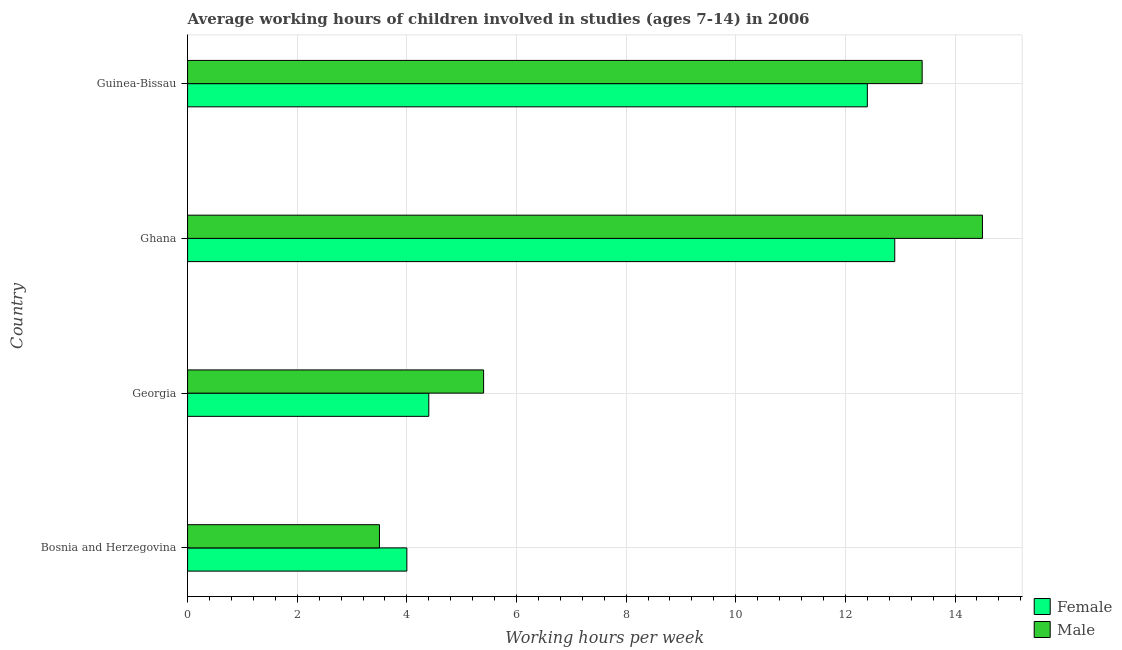How many different coloured bars are there?
Provide a succinct answer. 2. How many groups of bars are there?
Your answer should be compact. 4. Are the number of bars on each tick of the Y-axis equal?
Provide a short and direct response. Yes. How many bars are there on the 1st tick from the top?
Offer a terse response. 2. What is the label of the 3rd group of bars from the top?
Your answer should be very brief. Georgia. Across all countries, what is the minimum average working hour of male children?
Offer a terse response. 3.5. In which country was the average working hour of female children minimum?
Your answer should be very brief. Bosnia and Herzegovina. What is the total average working hour of male children in the graph?
Make the answer very short. 36.8. What is the difference between the average working hour of male children in Georgia and that in Ghana?
Your answer should be very brief. -9.1. What is the difference between the average working hour of male children in Ghana and the average working hour of female children in Bosnia and Herzegovina?
Offer a terse response. 10.5. What is the average average working hour of female children per country?
Make the answer very short. 8.43. In how many countries, is the average working hour of male children greater than 8 hours?
Make the answer very short. 2. What is the ratio of the average working hour of female children in Bosnia and Herzegovina to that in Georgia?
Your answer should be compact. 0.91. In how many countries, is the average working hour of male children greater than the average average working hour of male children taken over all countries?
Keep it short and to the point. 2. What does the 1st bar from the top in Georgia represents?
Give a very brief answer. Male. What does the 2nd bar from the bottom in Guinea-Bissau represents?
Your response must be concise. Male. What is the difference between two consecutive major ticks on the X-axis?
Provide a short and direct response. 2. Does the graph contain grids?
Ensure brevity in your answer.  Yes. Where does the legend appear in the graph?
Ensure brevity in your answer.  Bottom right. How many legend labels are there?
Provide a short and direct response. 2. What is the title of the graph?
Give a very brief answer. Average working hours of children involved in studies (ages 7-14) in 2006. What is the label or title of the X-axis?
Offer a terse response. Working hours per week. What is the Working hours per week of Female in Bosnia and Herzegovina?
Provide a succinct answer. 4. What is the Working hours per week in Male in Georgia?
Make the answer very short. 5.4. What is the Working hours per week in Female in Ghana?
Your response must be concise. 12.9. Across all countries, what is the maximum Working hours per week in Female?
Your answer should be very brief. 12.9. Across all countries, what is the maximum Working hours per week in Male?
Make the answer very short. 14.5. Across all countries, what is the minimum Working hours per week of Female?
Offer a very short reply. 4. What is the total Working hours per week in Female in the graph?
Offer a very short reply. 33.7. What is the total Working hours per week in Male in the graph?
Your answer should be compact. 36.8. What is the difference between the Working hours per week in Female in Bosnia and Herzegovina and that in Ghana?
Offer a terse response. -8.9. What is the difference between the Working hours per week of Male in Bosnia and Herzegovina and that in Ghana?
Provide a succinct answer. -11. What is the difference between the Working hours per week in Female in Bosnia and Herzegovina and that in Guinea-Bissau?
Give a very brief answer. -8.4. What is the difference between the Working hours per week of Female in Georgia and that in Ghana?
Ensure brevity in your answer.  -8.5. What is the difference between the Working hours per week in Female in Ghana and that in Guinea-Bissau?
Keep it short and to the point. 0.5. What is the difference between the Working hours per week of Male in Ghana and that in Guinea-Bissau?
Your answer should be compact. 1.1. What is the difference between the Working hours per week of Female in Bosnia and Herzegovina and the Working hours per week of Male in Ghana?
Your answer should be compact. -10.5. What is the difference between the Working hours per week in Female in Georgia and the Working hours per week in Male in Ghana?
Your answer should be compact. -10.1. What is the average Working hours per week of Female per country?
Provide a short and direct response. 8.43. What is the average Working hours per week of Male per country?
Your answer should be very brief. 9.2. What is the difference between the Working hours per week in Female and Working hours per week in Male in Bosnia and Herzegovina?
Give a very brief answer. 0.5. What is the difference between the Working hours per week in Female and Working hours per week in Male in Ghana?
Your response must be concise. -1.6. What is the ratio of the Working hours per week in Female in Bosnia and Herzegovina to that in Georgia?
Your response must be concise. 0.91. What is the ratio of the Working hours per week in Male in Bosnia and Herzegovina to that in Georgia?
Give a very brief answer. 0.65. What is the ratio of the Working hours per week of Female in Bosnia and Herzegovina to that in Ghana?
Your answer should be compact. 0.31. What is the ratio of the Working hours per week in Male in Bosnia and Herzegovina to that in Ghana?
Provide a short and direct response. 0.24. What is the ratio of the Working hours per week in Female in Bosnia and Herzegovina to that in Guinea-Bissau?
Keep it short and to the point. 0.32. What is the ratio of the Working hours per week in Male in Bosnia and Herzegovina to that in Guinea-Bissau?
Offer a very short reply. 0.26. What is the ratio of the Working hours per week of Female in Georgia to that in Ghana?
Offer a very short reply. 0.34. What is the ratio of the Working hours per week in Male in Georgia to that in Ghana?
Make the answer very short. 0.37. What is the ratio of the Working hours per week of Female in Georgia to that in Guinea-Bissau?
Offer a terse response. 0.35. What is the ratio of the Working hours per week in Male in Georgia to that in Guinea-Bissau?
Provide a succinct answer. 0.4. What is the ratio of the Working hours per week in Female in Ghana to that in Guinea-Bissau?
Provide a succinct answer. 1.04. What is the ratio of the Working hours per week in Male in Ghana to that in Guinea-Bissau?
Provide a succinct answer. 1.08. What is the difference between the highest and the second highest Working hours per week of Female?
Ensure brevity in your answer.  0.5. What is the difference between the highest and the second highest Working hours per week in Male?
Offer a terse response. 1.1. What is the difference between the highest and the lowest Working hours per week of Female?
Make the answer very short. 8.9. 